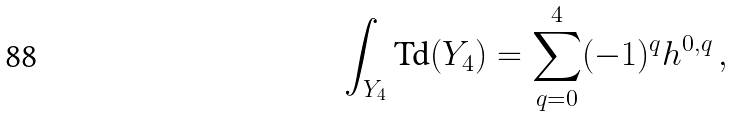<formula> <loc_0><loc_0><loc_500><loc_500>\int _ { Y _ { 4 } } \text {Td} ( Y _ { 4 } ) = \sum _ { q = 0 } ^ { 4 } ( - 1 ) ^ { q } h ^ { 0 , q } \, ,</formula> 